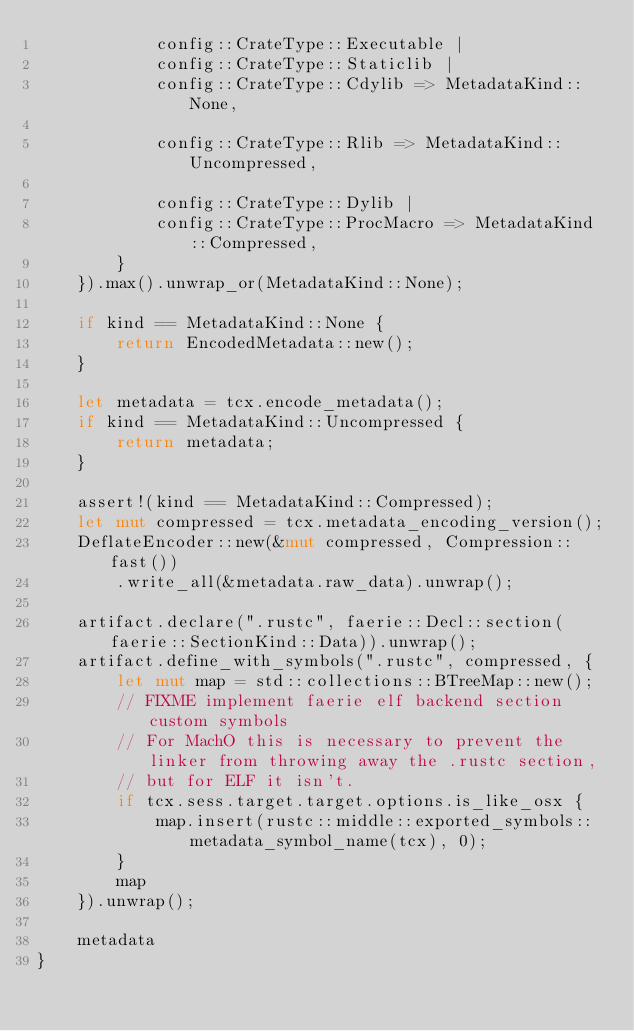Convert code to text. <code><loc_0><loc_0><loc_500><loc_500><_Rust_>            config::CrateType::Executable |
            config::CrateType::Staticlib |
            config::CrateType::Cdylib => MetadataKind::None,

            config::CrateType::Rlib => MetadataKind::Uncompressed,

            config::CrateType::Dylib |
            config::CrateType::ProcMacro => MetadataKind::Compressed,
        }
    }).max().unwrap_or(MetadataKind::None);

    if kind == MetadataKind::None {
        return EncodedMetadata::new();
    }

    let metadata = tcx.encode_metadata();
    if kind == MetadataKind::Uncompressed {
        return metadata;
    }

    assert!(kind == MetadataKind::Compressed);
    let mut compressed = tcx.metadata_encoding_version();
    DeflateEncoder::new(&mut compressed, Compression::fast())
        .write_all(&metadata.raw_data).unwrap();

    artifact.declare(".rustc", faerie::Decl::section(faerie::SectionKind::Data)).unwrap();
    artifact.define_with_symbols(".rustc", compressed, {
        let mut map = std::collections::BTreeMap::new();
        // FIXME implement faerie elf backend section custom symbols
        // For MachO this is necessary to prevent the linker from throwing away the .rustc section,
        // but for ELF it isn't.
        if tcx.sess.target.target.options.is_like_osx {
            map.insert(rustc::middle::exported_symbols::metadata_symbol_name(tcx), 0);
        }
        map
    }).unwrap();

    metadata
}
</code> 